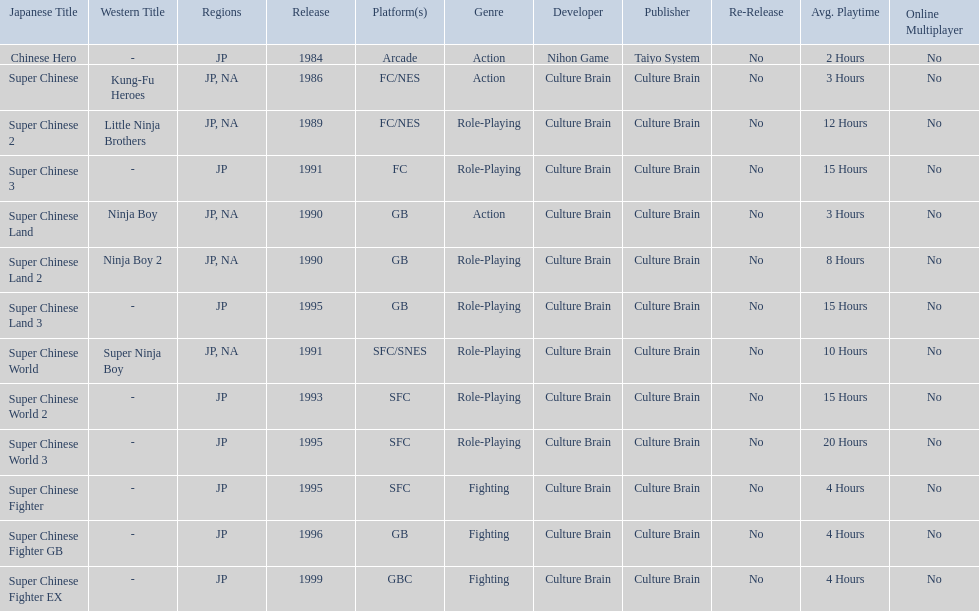When was the last super chinese game released? 1999. 